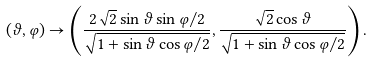<formula> <loc_0><loc_0><loc_500><loc_500>( \vartheta , \varphi ) \to \left ( \frac { 2 \sqrt { 2 } \sin \vartheta \sin \varphi / 2 } { \sqrt { 1 + \sin \vartheta \cos \varphi / 2 } } , \frac { \sqrt { 2 } \cos \vartheta } { \sqrt { 1 + \sin \vartheta \cos \varphi / 2 } } \right ) .</formula> 